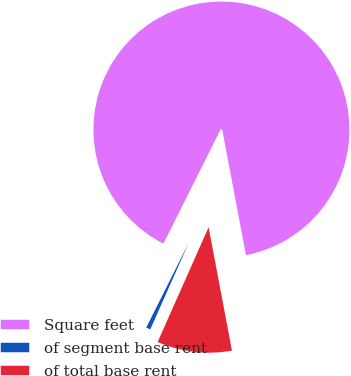<chart> <loc_0><loc_0><loc_500><loc_500><pie_chart><fcel>Square feet<fcel>of segment base rent<fcel>of total base rent<nl><fcel>89.63%<fcel>0.74%<fcel>9.63%<nl></chart> 